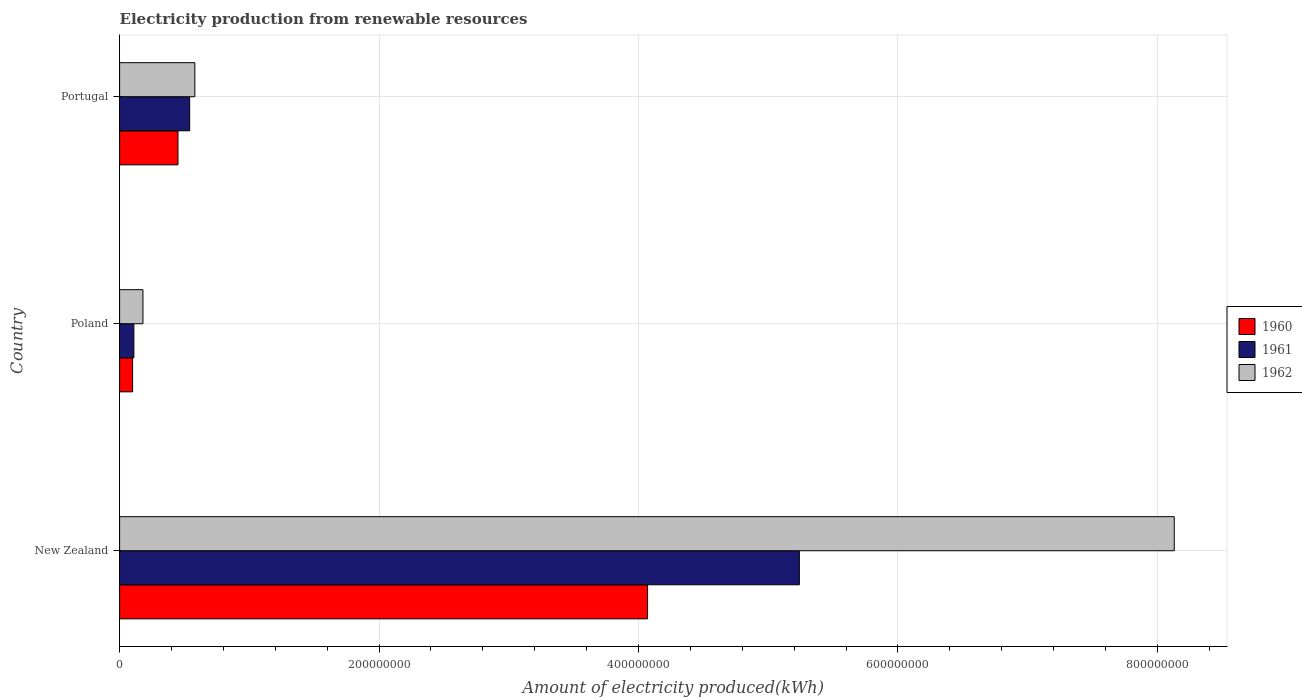How many different coloured bars are there?
Make the answer very short. 3. How many groups of bars are there?
Provide a succinct answer. 3. Are the number of bars on each tick of the Y-axis equal?
Provide a short and direct response. Yes. What is the label of the 3rd group of bars from the top?
Provide a short and direct response. New Zealand. What is the amount of electricity produced in 1960 in Portugal?
Your answer should be compact. 4.50e+07. Across all countries, what is the maximum amount of electricity produced in 1960?
Make the answer very short. 4.07e+08. Across all countries, what is the minimum amount of electricity produced in 1962?
Offer a terse response. 1.80e+07. In which country was the amount of electricity produced in 1961 maximum?
Provide a short and direct response. New Zealand. What is the total amount of electricity produced in 1961 in the graph?
Your answer should be compact. 5.89e+08. What is the difference between the amount of electricity produced in 1961 in New Zealand and that in Poland?
Provide a short and direct response. 5.13e+08. What is the difference between the amount of electricity produced in 1962 in Poland and the amount of electricity produced in 1960 in Portugal?
Provide a succinct answer. -2.70e+07. What is the average amount of electricity produced in 1962 per country?
Offer a very short reply. 2.96e+08. What is the difference between the amount of electricity produced in 1961 and amount of electricity produced in 1960 in New Zealand?
Your answer should be very brief. 1.17e+08. In how many countries, is the amount of electricity produced in 1962 greater than 320000000 kWh?
Your answer should be compact. 1. What is the ratio of the amount of electricity produced in 1962 in Poland to that in Portugal?
Provide a short and direct response. 0.31. Is the amount of electricity produced in 1960 in New Zealand less than that in Portugal?
Your answer should be compact. No. Is the difference between the amount of electricity produced in 1961 in New Zealand and Poland greater than the difference between the amount of electricity produced in 1960 in New Zealand and Poland?
Provide a short and direct response. Yes. What is the difference between the highest and the second highest amount of electricity produced in 1960?
Ensure brevity in your answer.  3.62e+08. What is the difference between the highest and the lowest amount of electricity produced in 1961?
Make the answer very short. 5.13e+08. In how many countries, is the amount of electricity produced in 1960 greater than the average amount of electricity produced in 1960 taken over all countries?
Give a very brief answer. 1. What does the 3rd bar from the bottom in Poland represents?
Offer a terse response. 1962. Is it the case that in every country, the sum of the amount of electricity produced in 1960 and amount of electricity produced in 1962 is greater than the amount of electricity produced in 1961?
Make the answer very short. Yes. How many bars are there?
Your response must be concise. 9. Does the graph contain grids?
Keep it short and to the point. Yes. How are the legend labels stacked?
Your response must be concise. Vertical. What is the title of the graph?
Your answer should be compact. Electricity production from renewable resources. Does "1973" appear as one of the legend labels in the graph?
Make the answer very short. No. What is the label or title of the X-axis?
Give a very brief answer. Amount of electricity produced(kWh). What is the label or title of the Y-axis?
Offer a terse response. Country. What is the Amount of electricity produced(kWh) of 1960 in New Zealand?
Offer a terse response. 4.07e+08. What is the Amount of electricity produced(kWh) in 1961 in New Zealand?
Provide a short and direct response. 5.24e+08. What is the Amount of electricity produced(kWh) of 1962 in New Zealand?
Your response must be concise. 8.13e+08. What is the Amount of electricity produced(kWh) of 1961 in Poland?
Provide a short and direct response. 1.10e+07. What is the Amount of electricity produced(kWh) in 1962 in Poland?
Offer a terse response. 1.80e+07. What is the Amount of electricity produced(kWh) in 1960 in Portugal?
Provide a short and direct response. 4.50e+07. What is the Amount of electricity produced(kWh) in 1961 in Portugal?
Give a very brief answer. 5.40e+07. What is the Amount of electricity produced(kWh) in 1962 in Portugal?
Your answer should be very brief. 5.80e+07. Across all countries, what is the maximum Amount of electricity produced(kWh) of 1960?
Keep it short and to the point. 4.07e+08. Across all countries, what is the maximum Amount of electricity produced(kWh) of 1961?
Offer a very short reply. 5.24e+08. Across all countries, what is the maximum Amount of electricity produced(kWh) of 1962?
Provide a short and direct response. 8.13e+08. Across all countries, what is the minimum Amount of electricity produced(kWh) of 1960?
Give a very brief answer. 1.00e+07. Across all countries, what is the minimum Amount of electricity produced(kWh) of 1961?
Keep it short and to the point. 1.10e+07. Across all countries, what is the minimum Amount of electricity produced(kWh) of 1962?
Provide a short and direct response. 1.80e+07. What is the total Amount of electricity produced(kWh) in 1960 in the graph?
Give a very brief answer. 4.62e+08. What is the total Amount of electricity produced(kWh) in 1961 in the graph?
Make the answer very short. 5.89e+08. What is the total Amount of electricity produced(kWh) in 1962 in the graph?
Your answer should be very brief. 8.89e+08. What is the difference between the Amount of electricity produced(kWh) of 1960 in New Zealand and that in Poland?
Your answer should be compact. 3.97e+08. What is the difference between the Amount of electricity produced(kWh) in 1961 in New Zealand and that in Poland?
Offer a terse response. 5.13e+08. What is the difference between the Amount of electricity produced(kWh) of 1962 in New Zealand and that in Poland?
Offer a terse response. 7.95e+08. What is the difference between the Amount of electricity produced(kWh) of 1960 in New Zealand and that in Portugal?
Provide a short and direct response. 3.62e+08. What is the difference between the Amount of electricity produced(kWh) in 1961 in New Zealand and that in Portugal?
Ensure brevity in your answer.  4.70e+08. What is the difference between the Amount of electricity produced(kWh) of 1962 in New Zealand and that in Portugal?
Give a very brief answer. 7.55e+08. What is the difference between the Amount of electricity produced(kWh) of 1960 in Poland and that in Portugal?
Keep it short and to the point. -3.50e+07. What is the difference between the Amount of electricity produced(kWh) of 1961 in Poland and that in Portugal?
Offer a terse response. -4.30e+07. What is the difference between the Amount of electricity produced(kWh) in 1962 in Poland and that in Portugal?
Keep it short and to the point. -4.00e+07. What is the difference between the Amount of electricity produced(kWh) in 1960 in New Zealand and the Amount of electricity produced(kWh) in 1961 in Poland?
Give a very brief answer. 3.96e+08. What is the difference between the Amount of electricity produced(kWh) in 1960 in New Zealand and the Amount of electricity produced(kWh) in 1962 in Poland?
Give a very brief answer. 3.89e+08. What is the difference between the Amount of electricity produced(kWh) in 1961 in New Zealand and the Amount of electricity produced(kWh) in 1962 in Poland?
Ensure brevity in your answer.  5.06e+08. What is the difference between the Amount of electricity produced(kWh) in 1960 in New Zealand and the Amount of electricity produced(kWh) in 1961 in Portugal?
Give a very brief answer. 3.53e+08. What is the difference between the Amount of electricity produced(kWh) of 1960 in New Zealand and the Amount of electricity produced(kWh) of 1962 in Portugal?
Offer a terse response. 3.49e+08. What is the difference between the Amount of electricity produced(kWh) of 1961 in New Zealand and the Amount of electricity produced(kWh) of 1962 in Portugal?
Ensure brevity in your answer.  4.66e+08. What is the difference between the Amount of electricity produced(kWh) in 1960 in Poland and the Amount of electricity produced(kWh) in 1961 in Portugal?
Offer a terse response. -4.40e+07. What is the difference between the Amount of electricity produced(kWh) in 1960 in Poland and the Amount of electricity produced(kWh) in 1962 in Portugal?
Keep it short and to the point. -4.80e+07. What is the difference between the Amount of electricity produced(kWh) of 1961 in Poland and the Amount of electricity produced(kWh) of 1962 in Portugal?
Ensure brevity in your answer.  -4.70e+07. What is the average Amount of electricity produced(kWh) in 1960 per country?
Your answer should be compact. 1.54e+08. What is the average Amount of electricity produced(kWh) of 1961 per country?
Offer a terse response. 1.96e+08. What is the average Amount of electricity produced(kWh) in 1962 per country?
Ensure brevity in your answer.  2.96e+08. What is the difference between the Amount of electricity produced(kWh) in 1960 and Amount of electricity produced(kWh) in 1961 in New Zealand?
Give a very brief answer. -1.17e+08. What is the difference between the Amount of electricity produced(kWh) in 1960 and Amount of electricity produced(kWh) in 1962 in New Zealand?
Offer a very short reply. -4.06e+08. What is the difference between the Amount of electricity produced(kWh) in 1961 and Amount of electricity produced(kWh) in 1962 in New Zealand?
Offer a very short reply. -2.89e+08. What is the difference between the Amount of electricity produced(kWh) in 1960 and Amount of electricity produced(kWh) in 1962 in Poland?
Give a very brief answer. -8.00e+06. What is the difference between the Amount of electricity produced(kWh) in 1961 and Amount of electricity produced(kWh) in 1962 in Poland?
Provide a succinct answer. -7.00e+06. What is the difference between the Amount of electricity produced(kWh) of 1960 and Amount of electricity produced(kWh) of 1961 in Portugal?
Keep it short and to the point. -9.00e+06. What is the difference between the Amount of electricity produced(kWh) of 1960 and Amount of electricity produced(kWh) of 1962 in Portugal?
Your response must be concise. -1.30e+07. What is the ratio of the Amount of electricity produced(kWh) in 1960 in New Zealand to that in Poland?
Your answer should be very brief. 40.7. What is the ratio of the Amount of electricity produced(kWh) of 1961 in New Zealand to that in Poland?
Your answer should be very brief. 47.64. What is the ratio of the Amount of electricity produced(kWh) in 1962 in New Zealand to that in Poland?
Your answer should be compact. 45.17. What is the ratio of the Amount of electricity produced(kWh) of 1960 in New Zealand to that in Portugal?
Your response must be concise. 9.04. What is the ratio of the Amount of electricity produced(kWh) of 1961 in New Zealand to that in Portugal?
Your response must be concise. 9.7. What is the ratio of the Amount of electricity produced(kWh) of 1962 in New Zealand to that in Portugal?
Offer a very short reply. 14.02. What is the ratio of the Amount of electricity produced(kWh) in 1960 in Poland to that in Portugal?
Provide a succinct answer. 0.22. What is the ratio of the Amount of electricity produced(kWh) in 1961 in Poland to that in Portugal?
Provide a short and direct response. 0.2. What is the ratio of the Amount of electricity produced(kWh) of 1962 in Poland to that in Portugal?
Your answer should be compact. 0.31. What is the difference between the highest and the second highest Amount of electricity produced(kWh) of 1960?
Give a very brief answer. 3.62e+08. What is the difference between the highest and the second highest Amount of electricity produced(kWh) of 1961?
Make the answer very short. 4.70e+08. What is the difference between the highest and the second highest Amount of electricity produced(kWh) in 1962?
Keep it short and to the point. 7.55e+08. What is the difference between the highest and the lowest Amount of electricity produced(kWh) in 1960?
Keep it short and to the point. 3.97e+08. What is the difference between the highest and the lowest Amount of electricity produced(kWh) of 1961?
Offer a terse response. 5.13e+08. What is the difference between the highest and the lowest Amount of electricity produced(kWh) in 1962?
Your answer should be compact. 7.95e+08. 